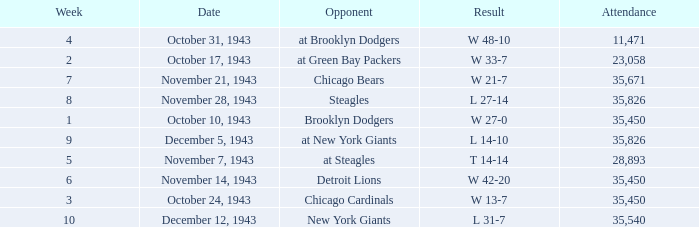How many attendances have 9 as the week? 1.0. 